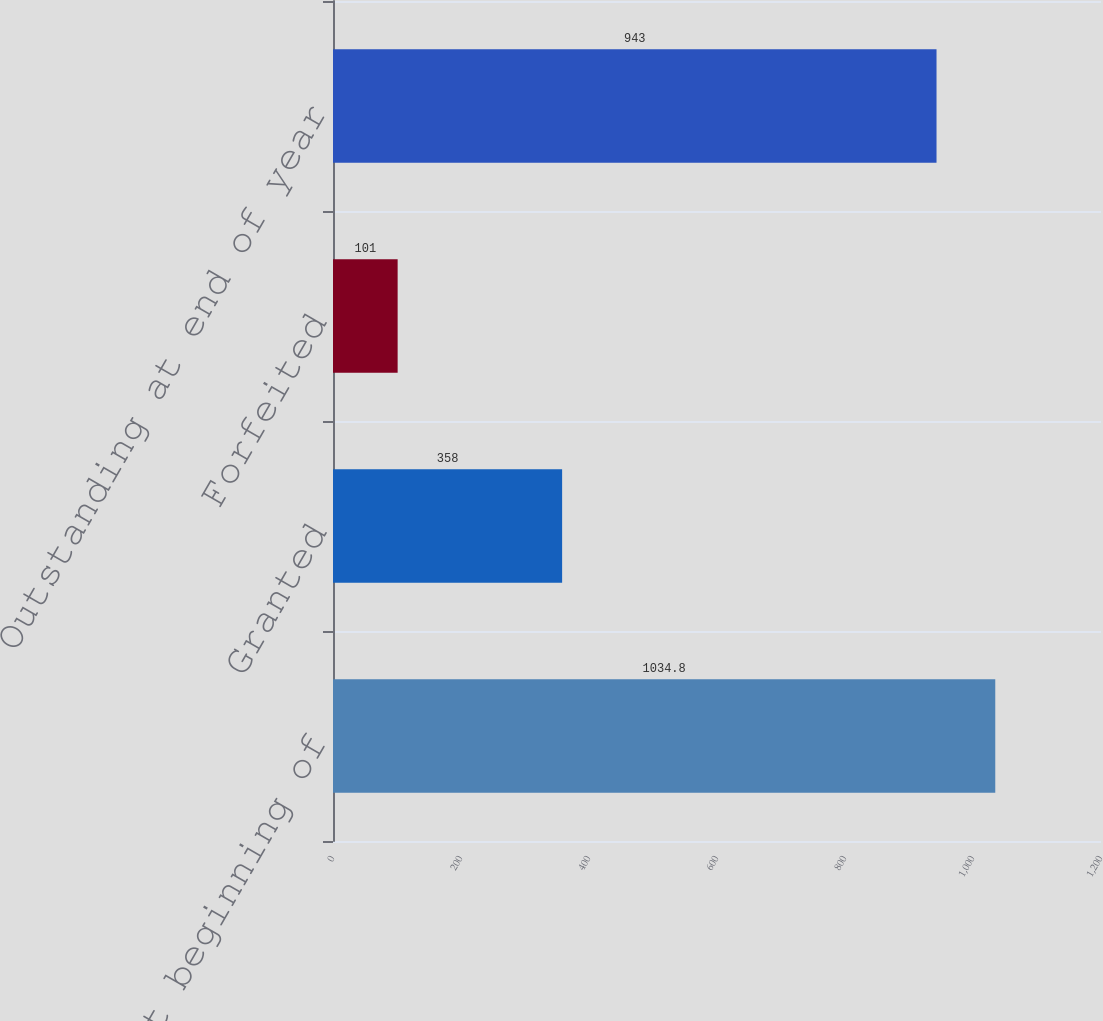Convert chart to OTSL. <chart><loc_0><loc_0><loc_500><loc_500><bar_chart><fcel>Outstanding at beginning of<fcel>Granted<fcel>Forfeited<fcel>Outstanding at end of year<nl><fcel>1034.8<fcel>358<fcel>101<fcel>943<nl></chart> 